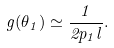Convert formula to latex. <formula><loc_0><loc_0><loc_500><loc_500>g ( \theta _ { 1 } ) \simeq \frac { 1 } { 2 p _ { 1 } l } .</formula> 